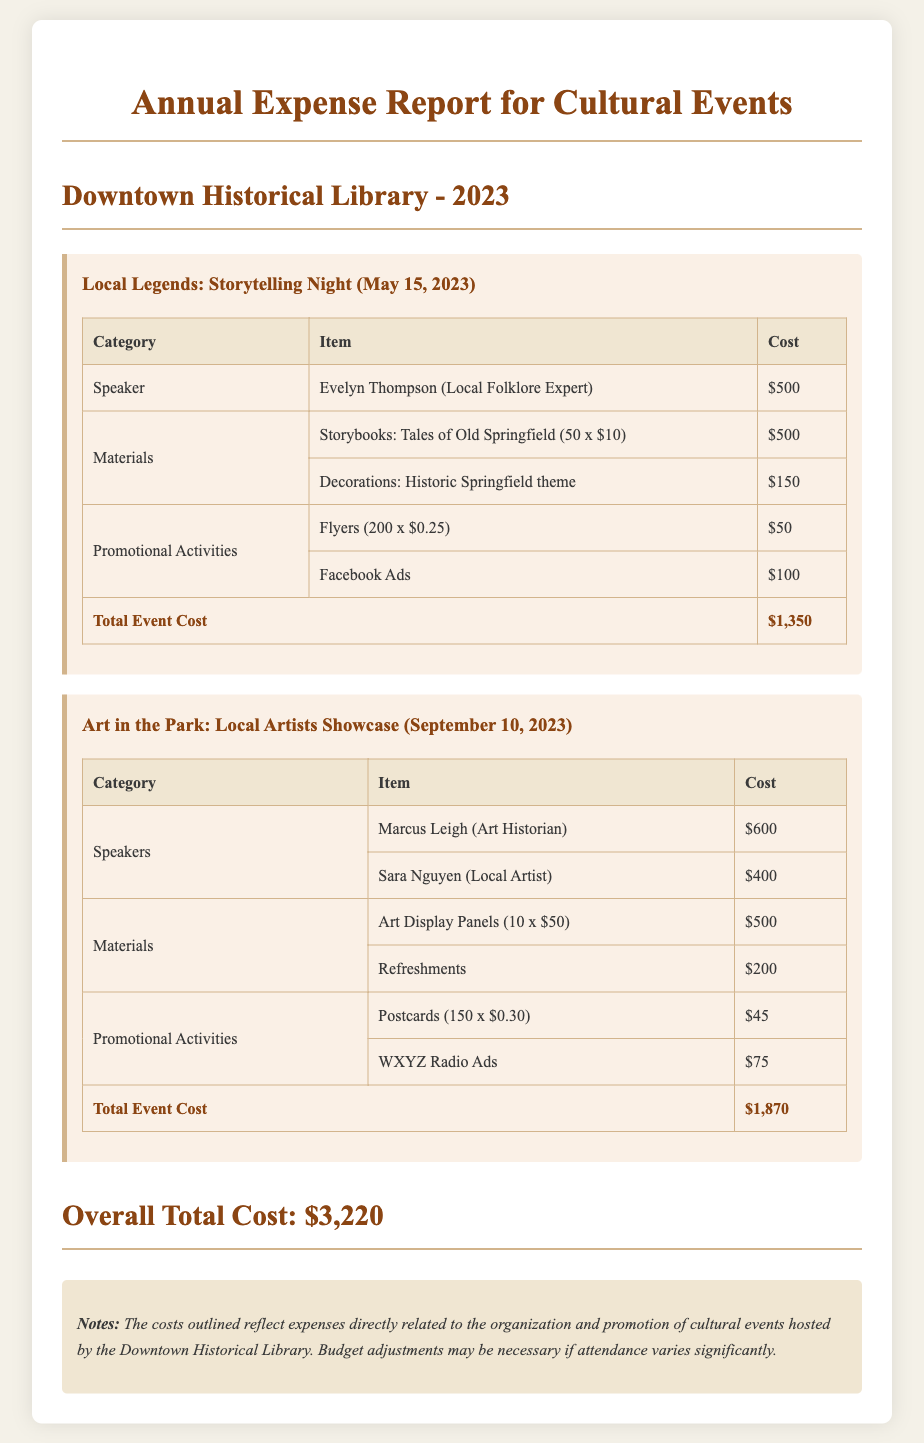What is the title of the report? The title is stated at the top of the document, indicating its focus on annual expenses for library-hosted cultural events.
Answer: Annual Expense Report for Cultural Events Who was the speaker for the Local Legends event? The document lists the speakers and their respective events, highlighting Evelyn Thompson as the speaker for this specific event.
Answer: Evelyn Thompson What was the total cost of the Local Legends event? The total cost for each event is summarized in a specific row at the bottom of the table for the Local Legends event.
Answer: $1,350 How many postcards were produced for the Art in the Park event? The documents detail the promotional materials for the Art in the Park event, indicating that 150 postcards were created.
Answer: 150 What is the overall total cost for all events? The report summarizes the total expenditure for both events in a specific section toward the end of the document.
Answer: $3,220 How much was spent on refreshments for the Art in the Park event? The materials section for the Art in the Park event specifies that funds were allocated for refreshments.
Answer: $200 Which category had the highest expense in the Local Legends event? A comparison of the expenses in the Local Legends event will show which category incurred the most costs, specified in the materials section.
Answer: Speaker What type of advertising was used for the Local Legends event? Promotional activities are listed under each event, stating that flyers and Facebook ads were utilized for the Local Legends event.
Answer: Flyers and Facebook Ads Who were the speakers at the Art in the Park event? The speakers for the Art in the Park event are detailed in the document, indicating the individuals who participated.
Answer: Marcus Leigh and Sara Nguyen 